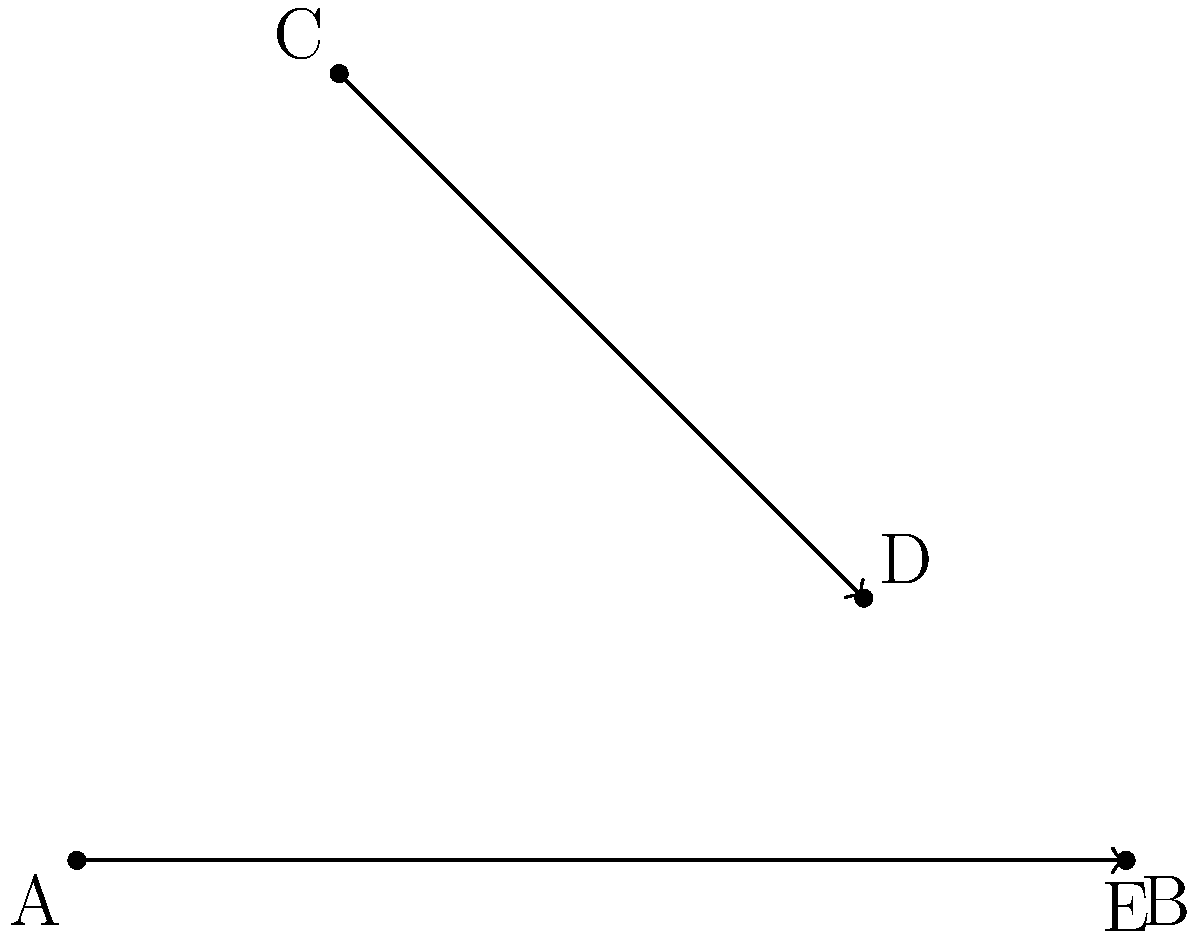In a scene reminiscent of a crossroads deal in Supernatural, two paths intersect at point E. Path AB represents a demon's trajectory, while path CD represents a hunter's path. If $\angle CED = 90°$, and the coordinates of the points are A(0,0), B(4,0), C(1,3), and D(3,1), what is the measure of the acute angle formed between these two paths? To find the acute angle between the two paths, we can follow these steps:

1) First, we need to find the slopes of both lines:

   Slope of AB: $m_1 = \frac{0-0}{4-0} = 0$
   Slope of CD: $m_2 = \frac{1-3}{3-1} = -1$

2) The tangent of the angle between two lines is given by the formula:

   $\tan \theta = |\frac{m_2 - m_1}{1 + m_1m_2}|$

3) Substituting our values:

   $\tan \theta = |\frac{-1 - 0}{1 + 0(-1)}| = |-1| = 1$

4) To find $\theta$, we take the inverse tangent (arctangent):

   $\theta = \arctan(1)$

5) $\arctan(1)$ is a well-known angle, equal to 45°.

Therefore, the acute angle between the two paths is 45°.
Answer: 45° 